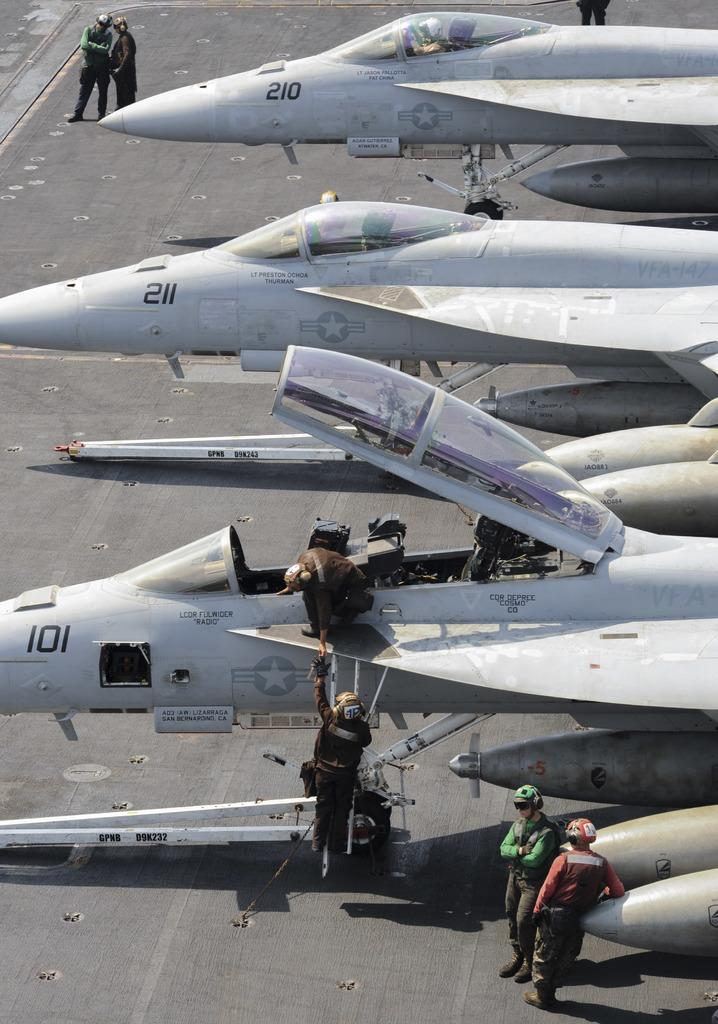What objects are on the floor in the image? There are aircrafts on the floor in the image. What can be seen in the background of the image? There are persons standing in the background of the image. What is the primary surface visible in the image? The background of the image includes the floor. What type of ray is visible in the image? There is no ray present in the image. What kind of plantation can be seen in the background of the image? There is no plantation visible in the image; it features aircrafts on the floor and persons standing in the background. 